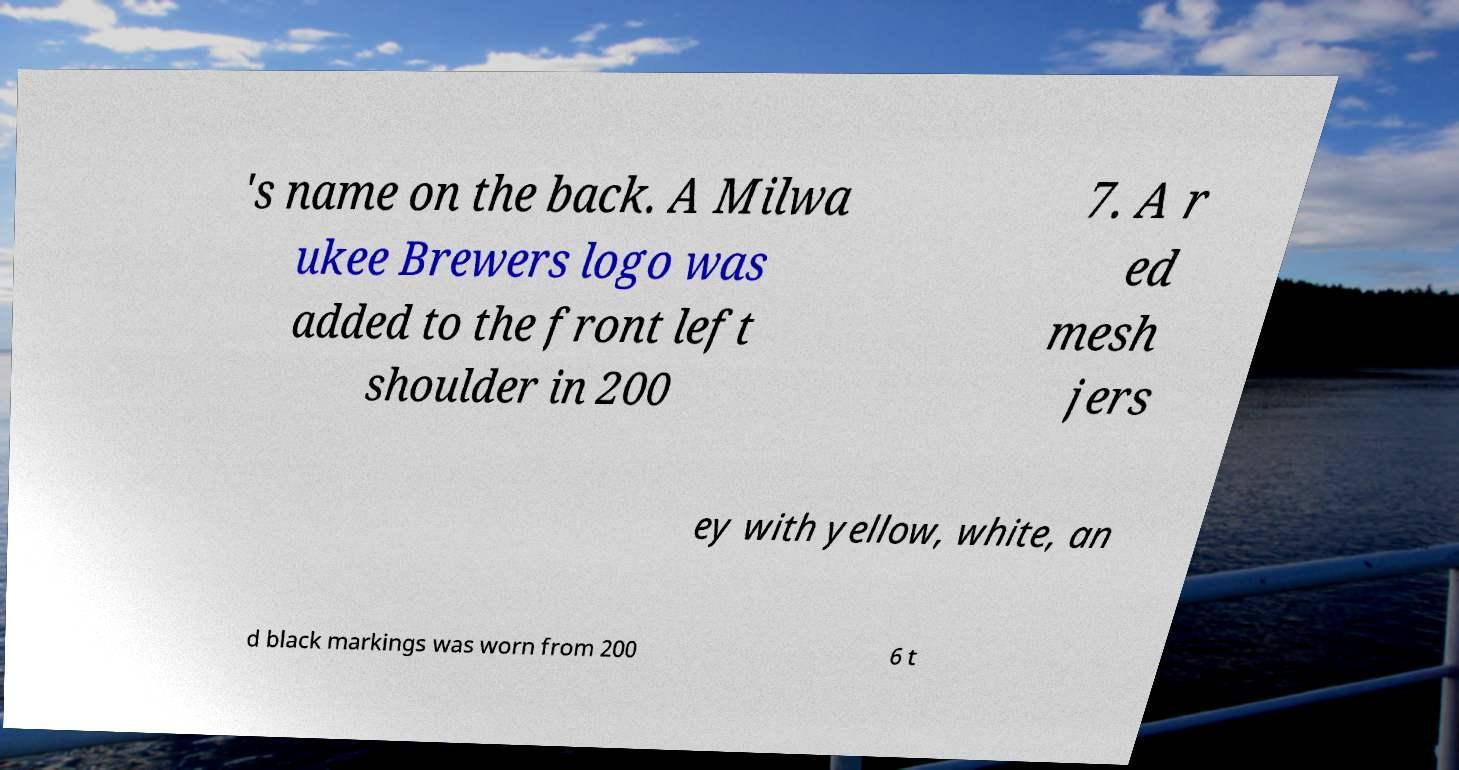Please identify and transcribe the text found in this image. 's name on the back. A Milwa ukee Brewers logo was added to the front left shoulder in 200 7. A r ed mesh jers ey with yellow, white, an d black markings was worn from 200 6 t 